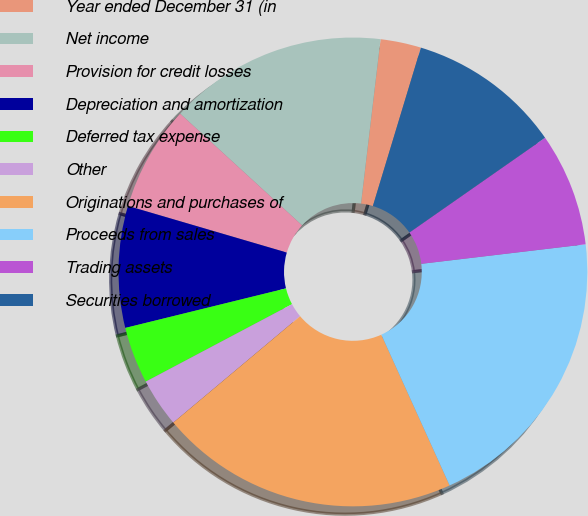Convert chart to OTSL. <chart><loc_0><loc_0><loc_500><loc_500><pie_chart><fcel>Year ended December 31 (in<fcel>Net income<fcel>Provision for credit losses<fcel>Depreciation and amortization<fcel>Deferred tax expense<fcel>Other<fcel>Originations and purchases of<fcel>Proceeds from sales<fcel>Trading assets<fcel>Securities borrowed<nl><fcel>2.8%<fcel>15.08%<fcel>7.26%<fcel>8.38%<fcel>3.91%<fcel>3.36%<fcel>20.66%<fcel>20.11%<fcel>7.82%<fcel>10.61%<nl></chart> 